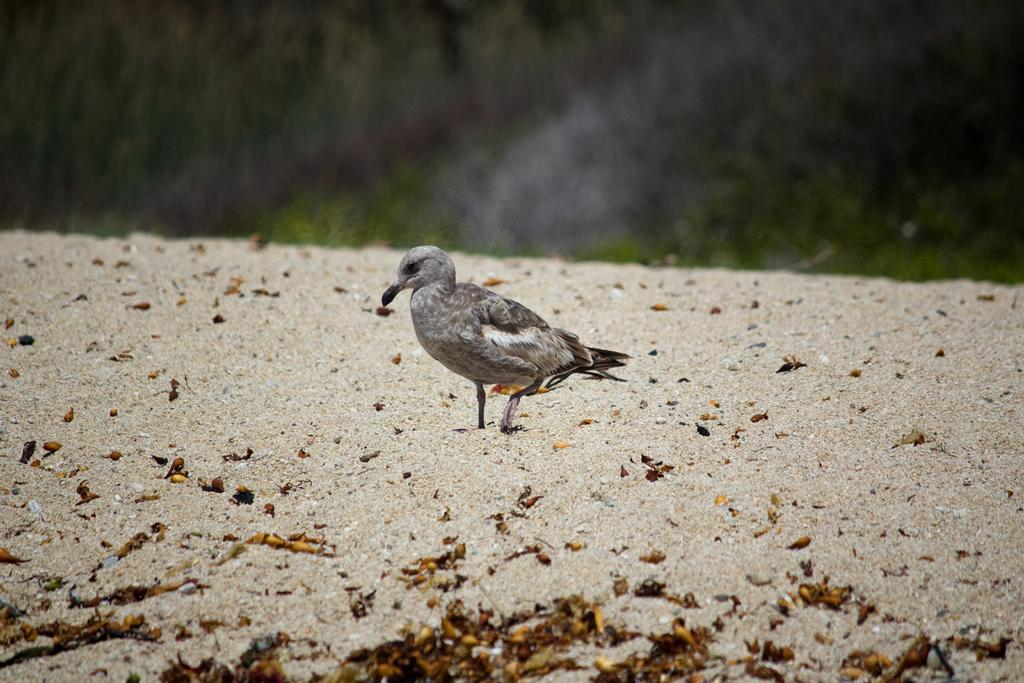What type of animal is in the image? There is a small bird in the image. Where is the bird located? The bird is standing on the ground. What can be seen in the front bottom side of the image? There are dry leaves in the front bottom side of the image. Can you describe the background of the image? The background of the image is blurred. What is the reason for the quince being present in the image? There is no quince present in the image, so there is no reason for it to be there. 